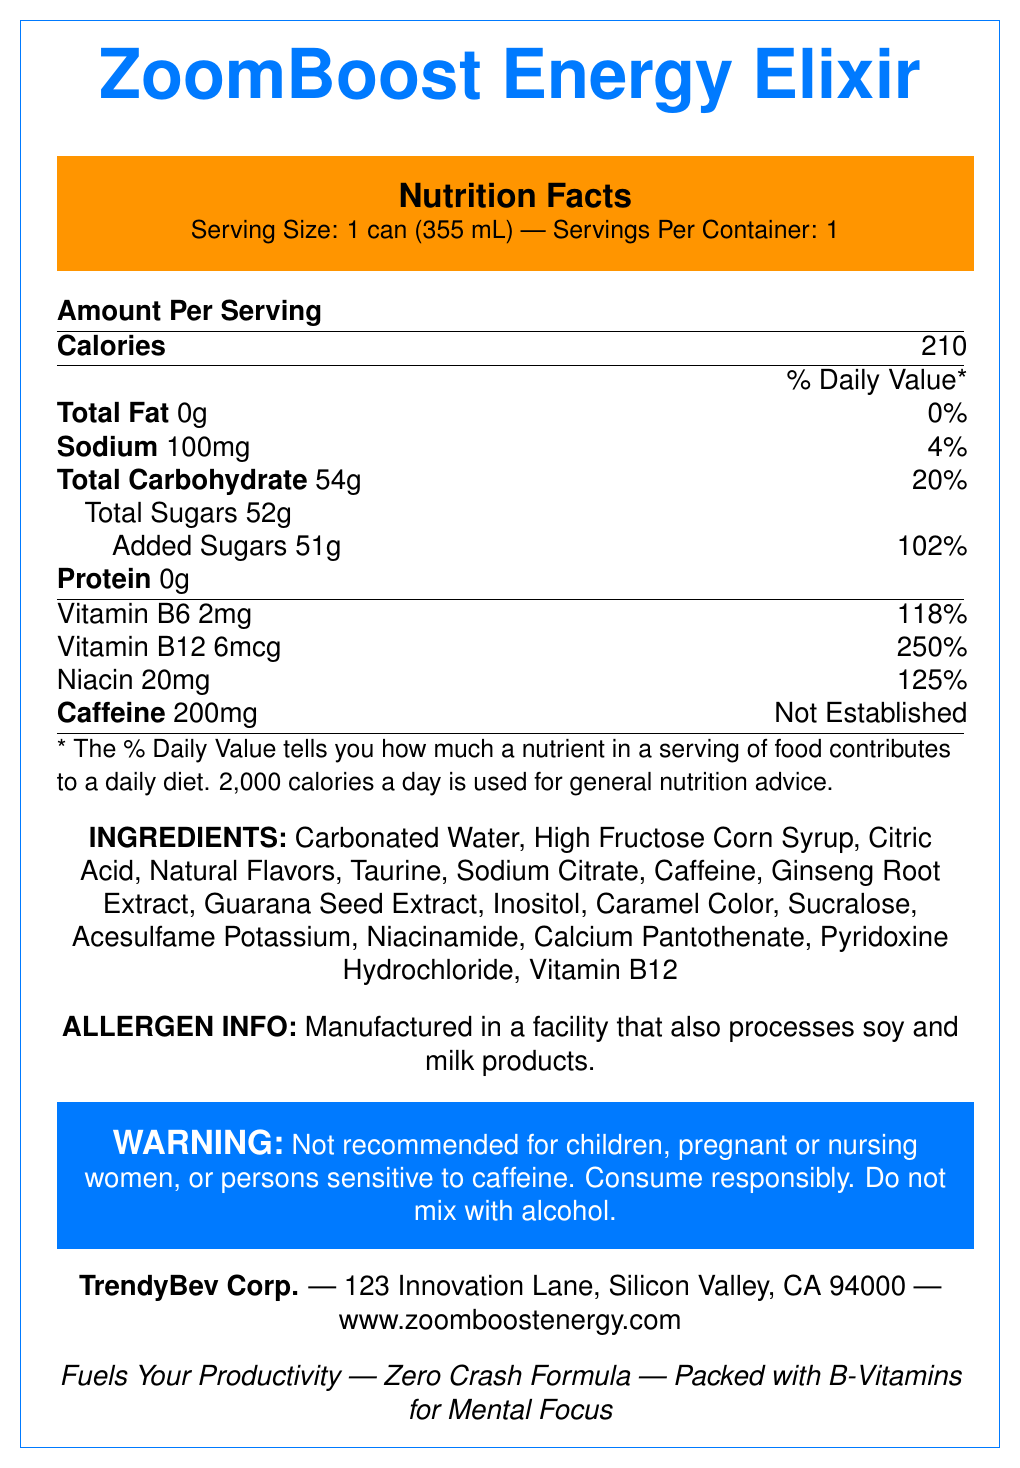what is the serving size? The serving size is clearly mentioned at the beginning of the Nutrition Facts section as "Serving Size: 1 can (355 mL)".
Answer: 1 can (355 mL) how much caffeine does a serving contain? The amount of caffeine per serving is listed in the document under the nutrition facts, indicating it contains 200mg.
Answer: 200mg what are the added sugars per serving? The label states that the amount of added sugars per serving is 51g, which contributes to 102% of the daily value.
Answer: 51g does the product contain any artificial ingredients? Ingredients such as high fructose corn syrup, sucralose, and acesulfame potassium are considered artificial.
Answer: Yes what percentage of the daily value for Vitamin B12 do you get from one serving? The document states that one serving provides 250% of the daily value for Vitamin B12.
Answer: 250% which company manufactures ZoomBoost Energy Elixir? A. Energy Drinks Inc. B. TrendyBev Corp. C. BoostCo Ltd. The company name TrendyBev Corp. is clearly listed under the company information section.
Answer: B. TrendyBev Corp. how many calories are in one can? A. 100 calories B. 150 calories C. 210 calories D. 250 calories The nutrition facts specify that there are 210 calories in one can.
Answer: C. 210 calories what is the main claim about the product's effect on productivity? A. Increases Physical Stamina B. Fuels Your Productivity C. Enhances Taste D. Reduces Anxiety This claim is listed in the marketing claims section of the document.
Answer: B. Fuels Your Productivity is the elixir recommended for children? The warning section specifically states that the elixir is not recommended for children, among other groups.
Answer: No describe the main features of ZoomBoost Energy Elixir based on the document. The explanation gives a comprehensive overview of the information presented in the document.
Answer: ZoomBoost Energy Elixir is an energy drink marketed to young professionals, with a serving size of 1 can (355 mL) containing 210 calories and 200mg of caffeine. It is composed of various ingredients, including artificial sweeteners and high fructose corn syrup, and is enriched with B-Vitamins. The product is not recommended for certain individuals and carries several marketing claims including "Fuels Your Productivity" and "Zero Crash Formula". It is manufactured by TrendyBev Corp., with contact details provided. what is the net weight of each serving in grams? The document only provides the serving size in milliliters (355 mL) and does not give enough information to determine the weight in grams.
Answer: Not enough information 